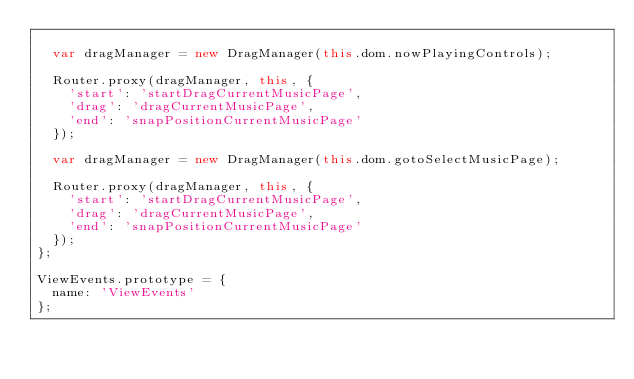<code> <loc_0><loc_0><loc_500><loc_500><_JavaScript_>
  var dragManager = new DragManager(this.dom.nowPlayingControls);

  Router.proxy(dragManager, this, {
    'start': 'startDragCurrentMusicPage',
    'drag': 'dragCurrentMusicPage',
    'end': 'snapPositionCurrentMusicPage'
  });

  var dragManager = new DragManager(this.dom.gotoSelectMusicPage);

  Router.proxy(dragManager, this, {
    'start': 'startDragCurrentMusicPage',
    'drag': 'dragCurrentMusicPage',
    'end': 'snapPositionCurrentMusicPage'
  });
};

ViewEvents.prototype = {
  name: 'ViewEvents'
};
</code> 